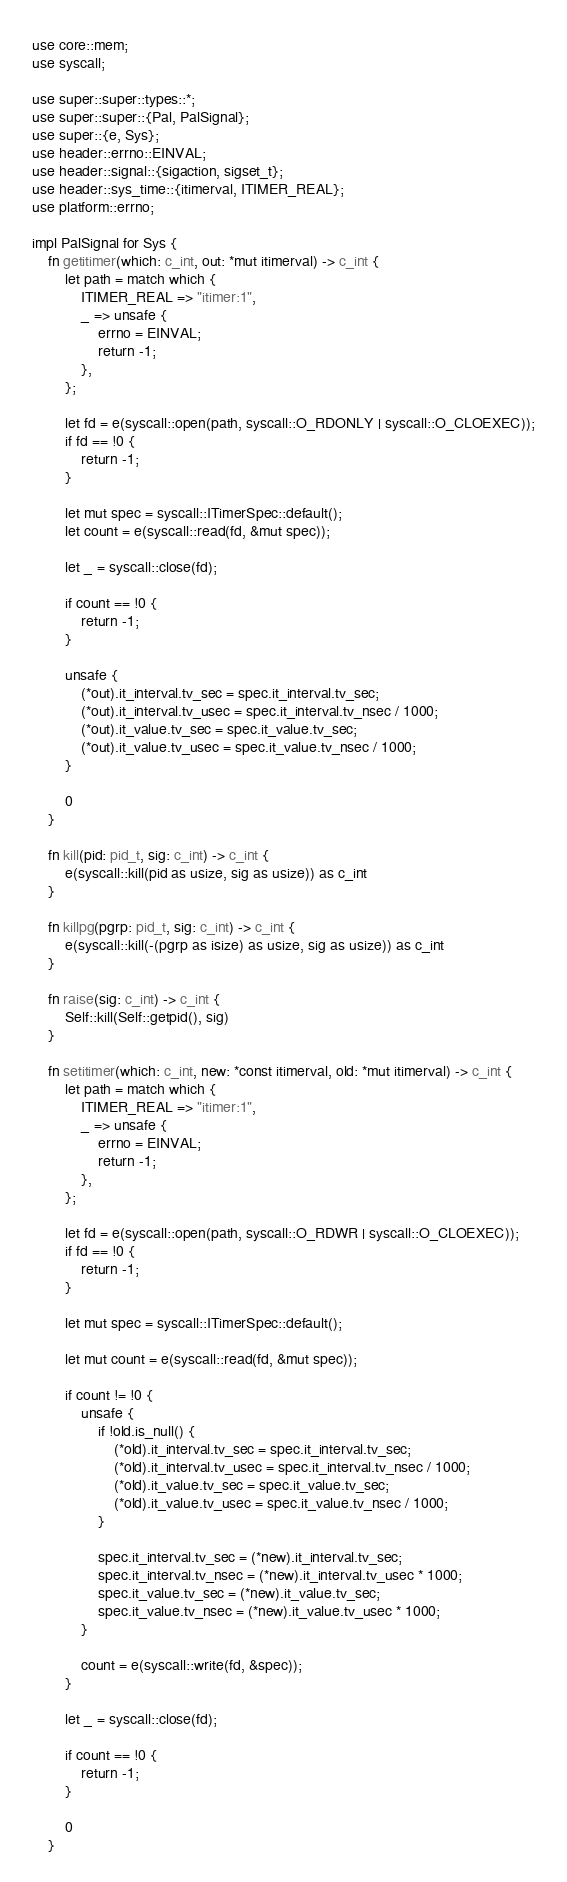<code> <loc_0><loc_0><loc_500><loc_500><_Rust_>use core::mem;
use syscall;

use super::super::types::*;
use super::super::{Pal, PalSignal};
use super::{e, Sys};
use header::errno::EINVAL;
use header::signal::{sigaction, sigset_t};
use header::sys_time::{itimerval, ITIMER_REAL};
use platform::errno;

impl PalSignal for Sys {
    fn getitimer(which: c_int, out: *mut itimerval) -> c_int {
        let path = match which {
            ITIMER_REAL => "itimer:1",
            _ => unsafe {
                errno = EINVAL;
                return -1;
            },
        };

        let fd = e(syscall::open(path, syscall::O_RDONLY | syscall::O_CLOEXEC));
        if fd == !0 {
            return -1;
        }

        let mut spec = syscall::ITimerSpec::default();
        let count = e(syscall::read(fd, &mut spec));

        let _ = syscall::close(fd);

        if count == !0 {
            return -1;
        }

        unsafe {
            (*out).it_interval.tv_sec = spec.it_interval.tv_sec;
            (*out).it_interval.tv_usec = spec.it_interval.tv_nsec / 1000;
            (*out).it_value.tv_sec = spec.it_value.tv_sec;
            (*out).it_value.tv_usec = spec.it_value.tv_nsec / 1000;
        }

        0
    }

    fn kill(pid: pid_t, sig: c_int) -> c_int {
        e(syscall::kill(pid as usize, sig as usize)) as c_int
    }

    fn killpg(pgrp: pid_t, sig: c_int) -> c_int {
        e(syscall::kill(-(pgrp as isize) as usize, sig as usize)) as c_int
    }

    fn raise(sig: c_int) -> c_int {
        Self::kill(Self::getpid(), sig)
    }

    fn setitimer(which: c_int, new: *const itimerval, old: *mut itimerval) -> c_int {
        let path = match which {
            ITIMER_REAL => "itimer:1",
            _ => unsafe {
                errno = EINVAL;
                return -1;
            },
        };

        let fd = e(syscall::open(path, syscall::O_RDWR | syscall::O_CLOEXEC));
        if fd == !0 {
            return -1;
        }

        let mut spec = syscall::ITimerSpec::default();

        let mut count = e(syscall::read(fd, &mut spec));

        if count != !0 {
            unsafe {
                if !old.is_null() {
                    (*old).it_interval.tv_sec = spec.it_interval.tv_sec;
                    (*old).it_interval.tv_usec = spec.it_interval.tv_nsec / 1000;
                    (*old).it_value.tv_sec = spec.it_value.tv_sec;
                    (*old).it_value.tv_usec = spec.it_value.tv_nsec / 1000;
                }

                spec.it_interval.tv_sec = (*new).it_interval.tv_sec;
                spec.it_interval.tv_nsec = (*new).it_interval.tv_usec * 1000;
                spec.it_value.tv_sec = (*new).it_value.tv_sec;
                spec.it_value.tv_nsec = (*new).it_value.tv_usec * 1000;
            }

            count = e(syscall::write(fd, &spec));
        }

        let _ = syscall::close(fd);

        if count == !0 {
            return -1;
        }

        0
    }
</code> 